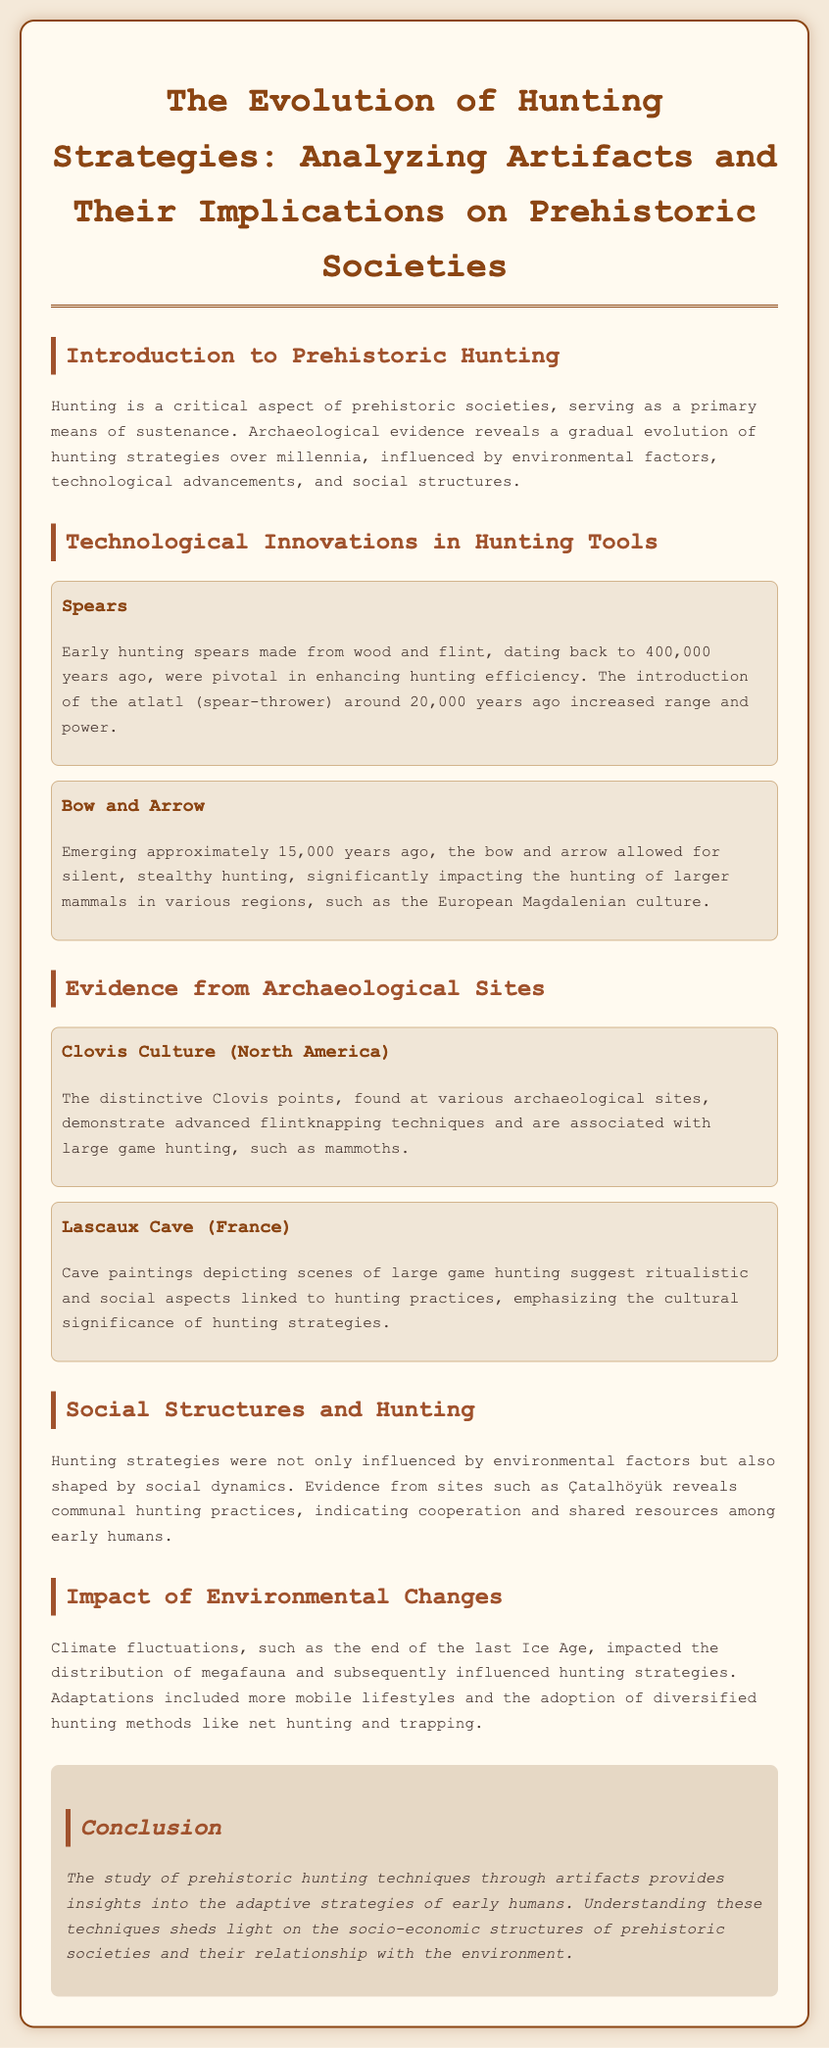what are the early hunting spears made from? The document states that early hunting spears were made from wood and flint.
Answer: wood and flint when did the atlatl first appear? The document mentions the introduction of the atlatl around 20,000 years ago.
Answer: 20,000 years ago which prehistoric culture is associated with large game hunting in North America? The Clovis culture is described as being associated with large game hunting.
Answer: Clovis Culture what type of hunting does the bow and arrow facilitate? The document indicates that the bow and arrow allowed for silent, stealthy hunting.
Answer: silent, stealthy hunting how did climate fluctuations impact hunting strategies? The document explains that climate fluctuations led to more mobile lifestyles and the adoption of diversified hunting methods.
Answer: mobile lifestyles and diversified hunting methods what is emphasized by the cave paintings in Lascaux Cave? The cave paintings emphasize the cultural significance of hunting strategies.
Answer: cultural significance of hunting strategies what aspect of prehistoric societies does the study of hunting techniques illuminate? The study of prehistoric hunting techniques sheds light on socio-economic structures of prehistoric societies.
Answer: socio-economic structures which site reveals communal hunting practices? The document suggests that evidence from Çatalhöyük reveals communal hunting practices.
Answer: Çatalhöyük 